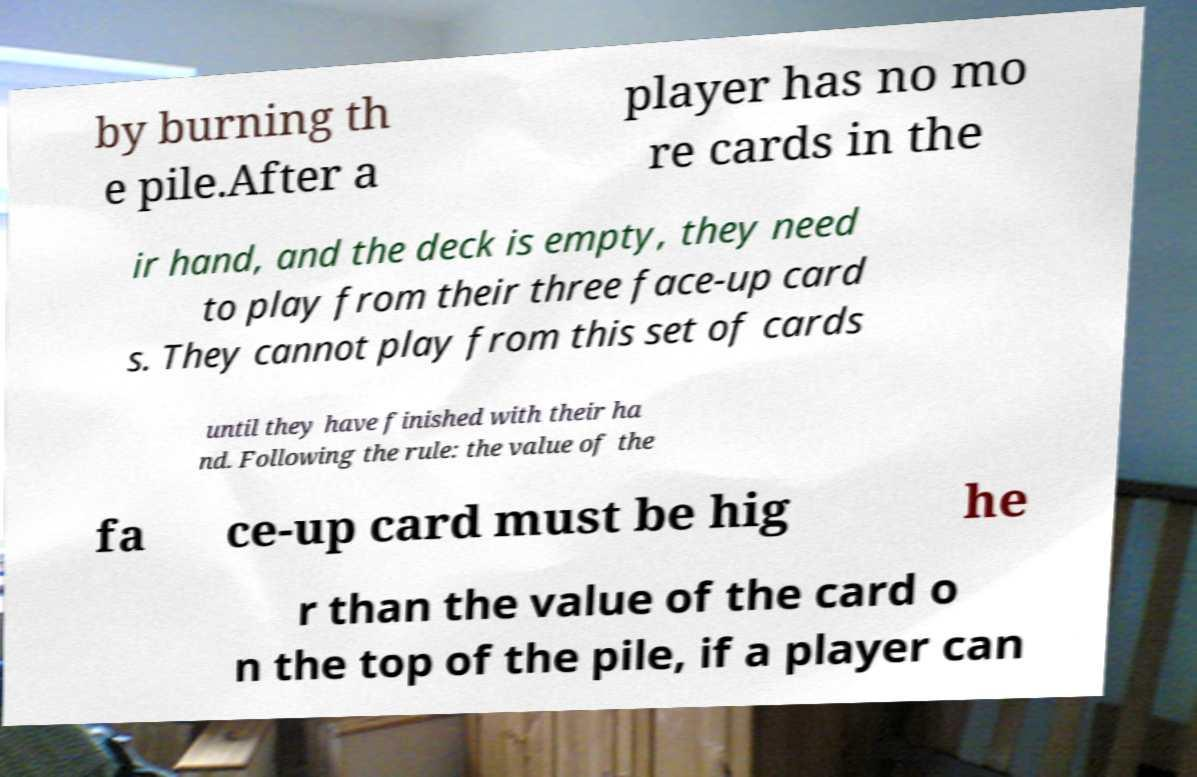Can you accurately transcribe the text from the provided image for me? by burning th e pile.After a player has no mo re cards in the ir hand, and the deck is empty, they need to play from their three face-up card s. They cannot play from this set of cards until they have finished with their ha nd. Following the rule: the value of the fa ce-up card must be hig he r than the value of the card o n the top of the pile, if a player can 